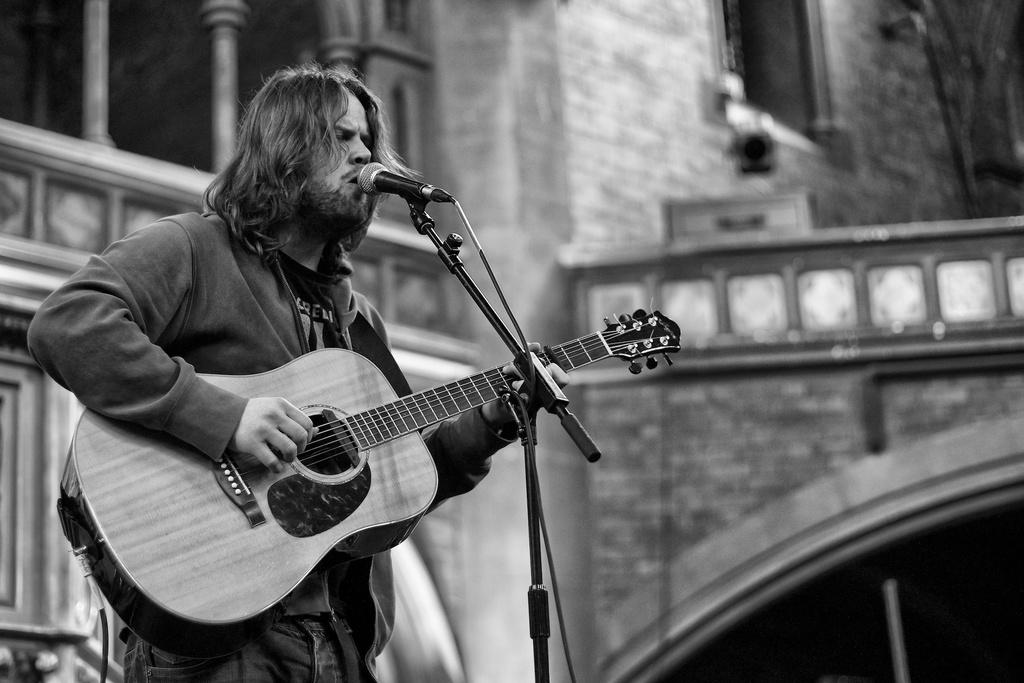What is the man in the image doing? The man is singing in the image. What instrument is the man holding? The man is holding a guitar. How is the man's voice being amplified? The man is using a microphone. What is in front of the man? There is a stand in front of the man. What can be seen in the background of the image? There is a wall and a building in the background of the image. What type of holiday is the man celebrating in the image? There is no indication of a holiday in the image; the man is simply singing with a guitar and microphone. How does the room's acoustics affect the man's performance in the image? The provided facts do not mention anything about the room's acoustics, so it cannot be determined how they might affect the man's performance. 